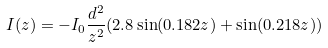<formula> <loc_0><loc_0><loc_500><loc_500>I ( z ) = - I _ { 0 } \frac { d ^ { 2 } } { z ^ { 2 } } ( 2 . 8 \sin ( 0 . 1 8 2 z ) + \sin ( 0 . 2 1 8 z ) )</formula> 